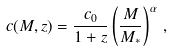Convert formula to latex. <formula><loc_0><loc_0><loc_500><loc_500>c ( M , z ) = \frac { c _ { 0 } } { 1 + z } \left ( \frac { M } { M _ { * } } \right ) ^ { \alpha } \, ,</formula> 